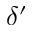Convert formula to latex. <formula><loc_0><loc_0><loc_500><loc_500>\delta ^ { \prime }</formula> 